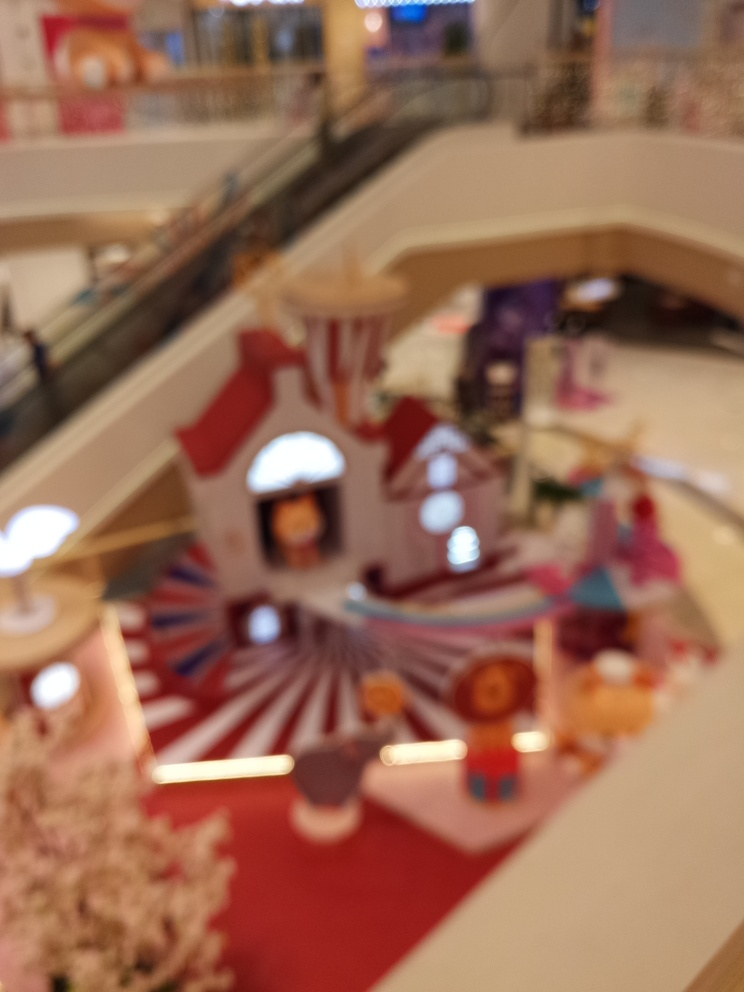Could you describe what this place might be used for, assuming the image were in focus? Based on the blurred shapes and colors, it appears to be an indoor setting with a decorative floor and possibly some seating areas or displays. It could be a shopping mall, an exhibition area, or a public event space designed for social gatherings and activities. 